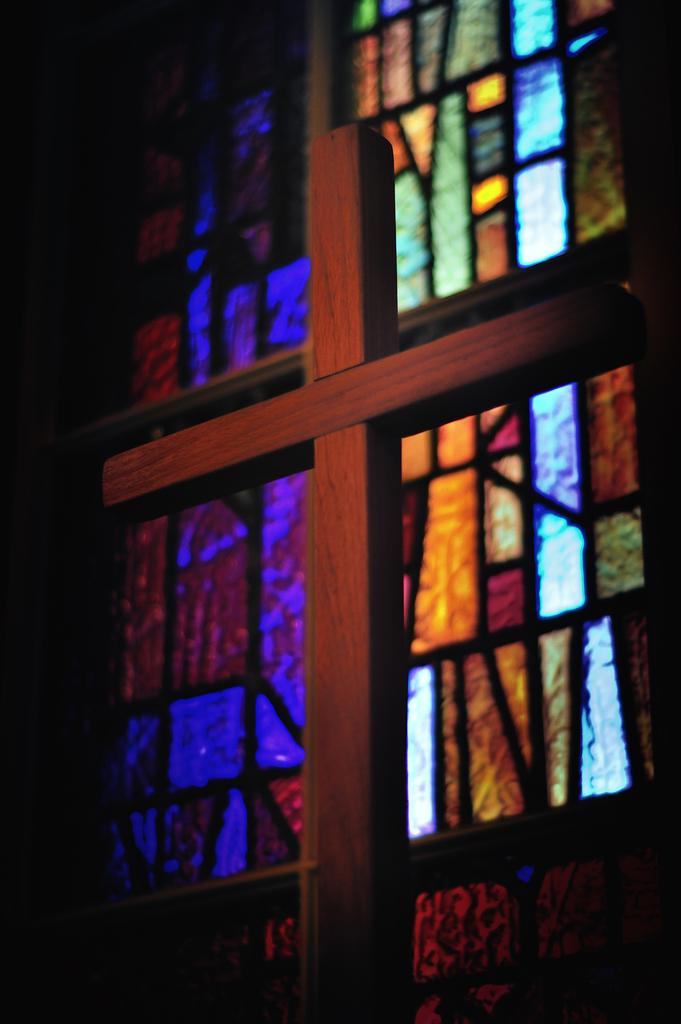What religious symbol is present in the image? There is a cross in the image. What can be seen in the background of the image? There is a window with stained glass in the background of the image. What type of key is used to unlock the basin in the image? There is no basin present in the image, so it is not possible to determine what type of key might be used to unlock it. 